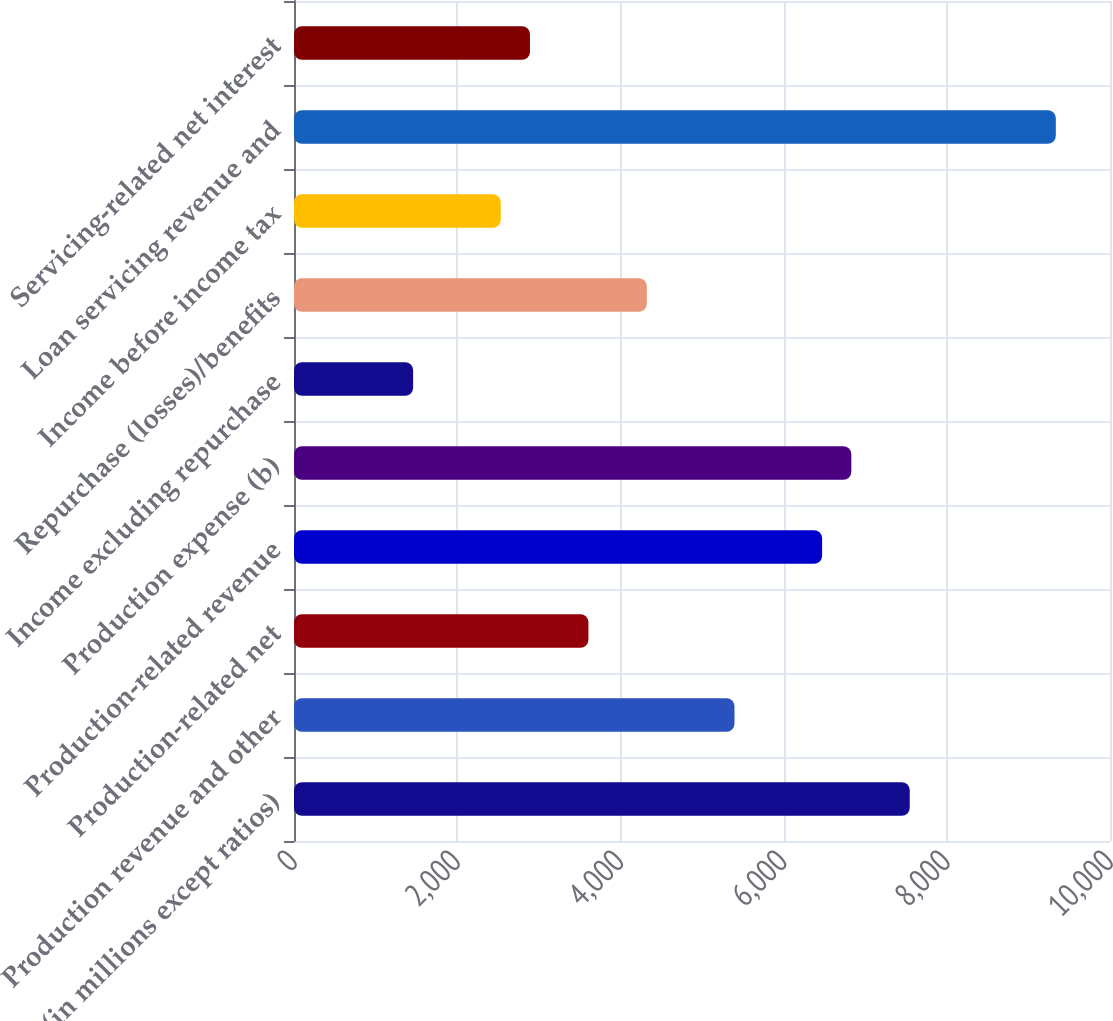Convert chart to OTSL. <chart><loc_0><loc_0><loc_500><loc_500><bar_chart><fcel>(in millions except ratios)<fcel>Production revenue and other<fcel>Production-related net<fcel>Production-related revenue<fcel>Production expense (b)<fcel>Income excluding repurchase<fcel>Repurchase (losses)/benefits<fcel>Income before income tax<fcel>Loan servicing revenue and<fcel>Servicing-related net interest<nl><fcel>7546<fcel>5398<fcel>3608<fcel>6472<fcel>6830<fcel>1460<fcel>4324<fcel>2534<fcel>9336<fcel>2892<nl></chart> 